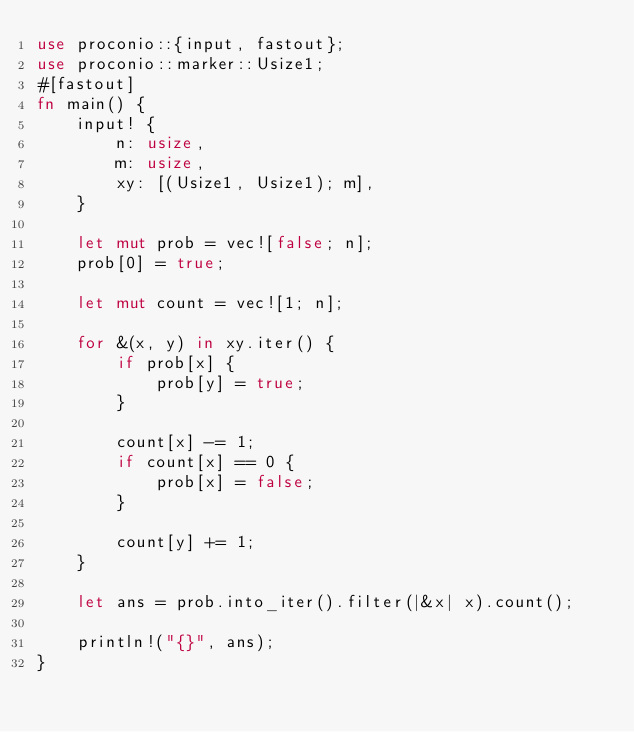<code> <loc_0><loc_0><loc_500><loc_500><_Rust_>use proconio::{input, fastout};
use proconio::marker::Usize1;
#[fastout]
fn main() {
    input! {
        n: usize,
        m: usize,
        xy: [(Usize1, Usize1); m],
    }

    let mut prob = vec![false; n];
    prob[0] = true;

    let mut count = vec![1; n];

    for &(x, y) in xy.iter() {
        if prob[x] {
            prob[y] = true;
        }

        count[x] -= 1;
        if count[x] == 0 {
            prob[x] = false;
        }

        count[y] += 1;
    }

    let ans = prob.into_iter().filter(|&x| x).count();

    println!("{}", ans);
}</code> 